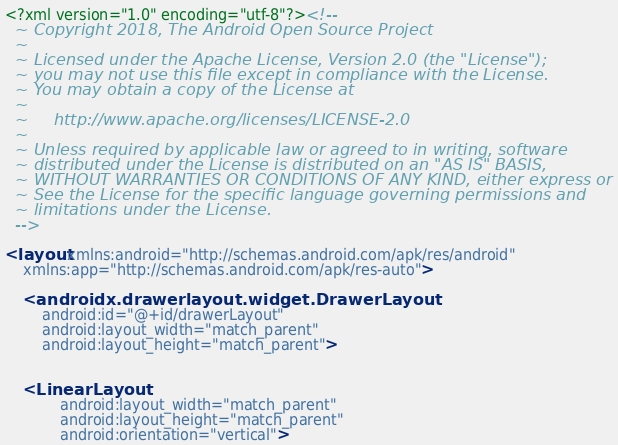<code> <loc_0><loc_0><loc_500><loc_500><_XML_><?xml version="1.0" encoding="utf-8"?><!--
  ~ Copyright 2018, The Android Open Source Project
  ~
  ~ Licensed under the Apache License, Version 2.0 (the "License");
  ~ you may not use this file except in compliance with the License.
  ~ You may obtain a copy of the License at
  ~
  ~     http://www.apache.org/licenses/LICENSE-2.0
  ~
  ~ Unless required by applicable law or agreed to in writing, software
  ~ distributed under the License is distributed on an "AS IS" BASIS,
  ~ WITHOUT WARRANTIES OR CONDITIONS OF ANY KIND, either express or implied.
  ~ See the License for the specific language governing permissions and
  ~ limitations under the License.
  -->

<layout xmlns:android="http://schemas.android.com/apk/res/android"
    xmlns:app="http://schemas.android.com/apk/res-auto">

    <androidx.drawerlayout.widget.DrawerLayout
        android:id="@+id/drawerLayout"
        android:layout_width="match_parent"
        android:layout_height="match_parent">


    <LinearLayout
            android:layout_width="match_parent"
            android:layout_height="match_parent"
            android:orientation="vertical">
</code> 